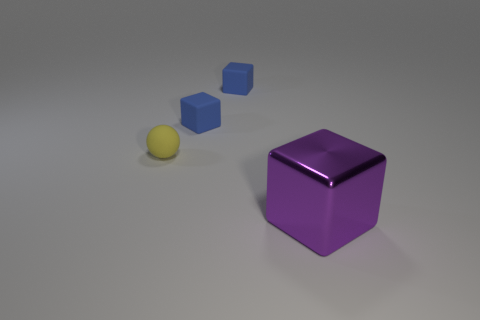There is a object in front of the tiny rubber ball; what is its shape? cube 